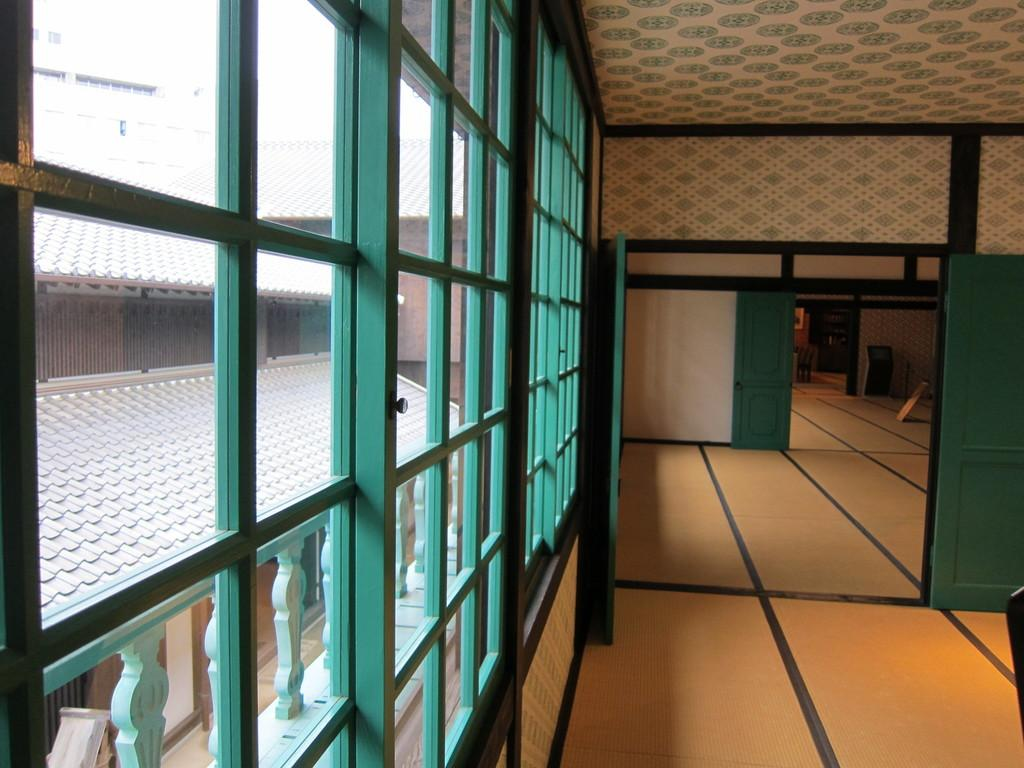What type of view is shown in the image? The image shows an inside view of a building. What objects can be seen on the left side of the image? There are glasses on the left side of the image. What can be seen through the glasses in the image? More buildings are visible through the glasses. What type of clover is growing on the floor in the image? There is no clover present in the image; it is an inside view of a building with glasses on the left side. 